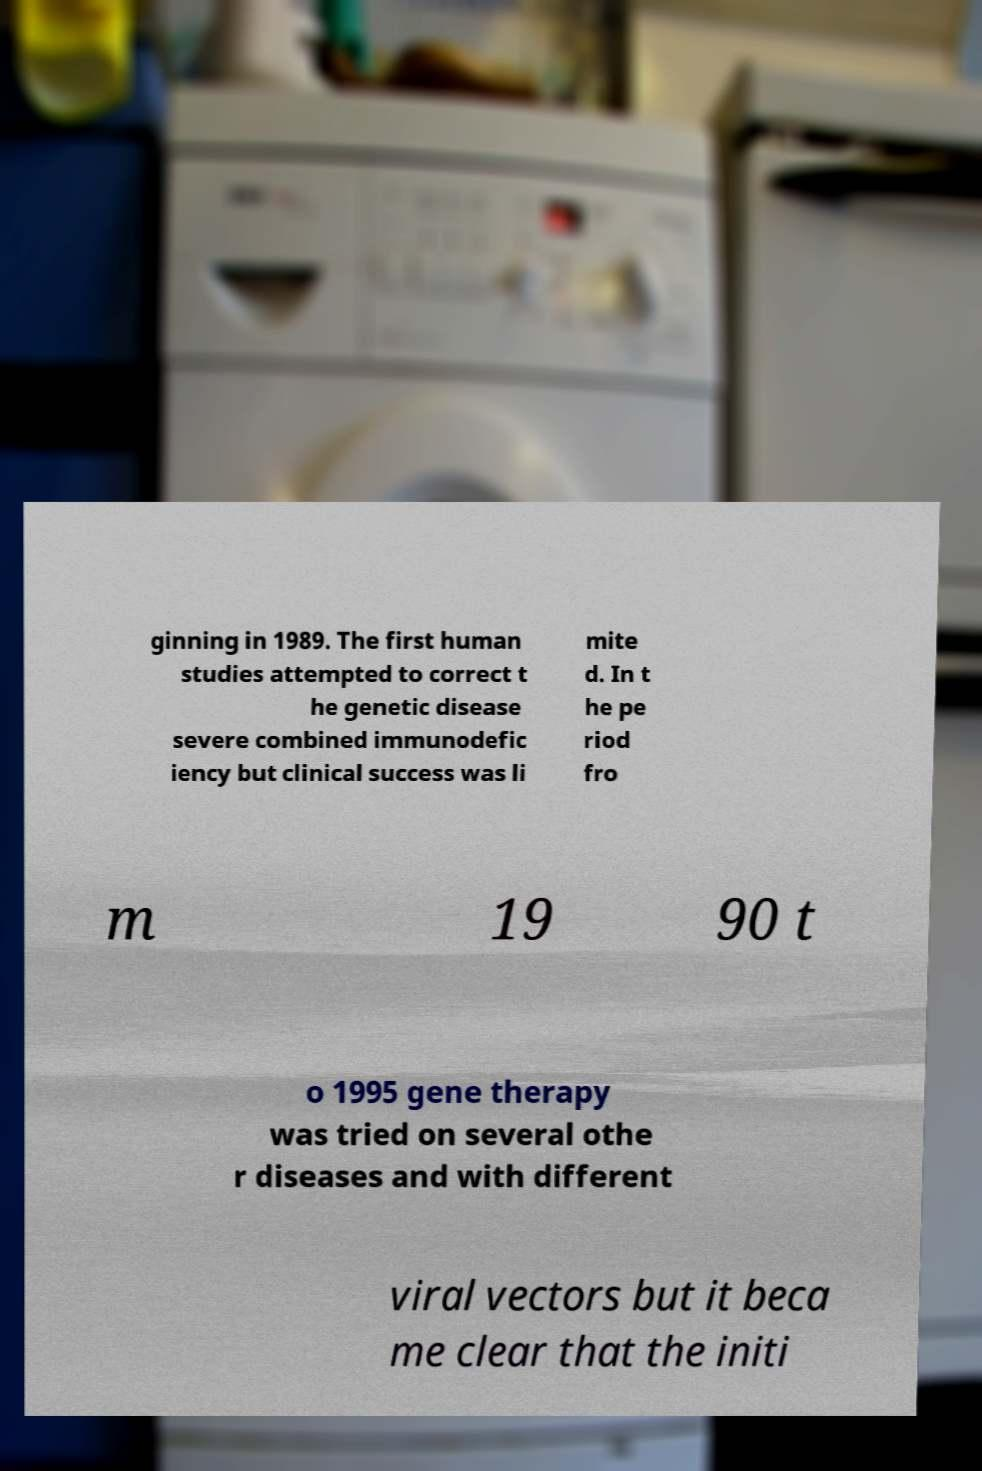Can you read and provide the text displayed in the image?This photo seems to have some interesting text. Can you extract and type it out for me? ginning in 1989. The first human studies attempted to correct t he genetic disease severe combined immunodefic iency but clinical success was li mite d. In t he pe riod fro m 19 90 t o 1995 gene therapy was tried on several othe r diseases and with different viral vectors but it beca me clear that the initi 